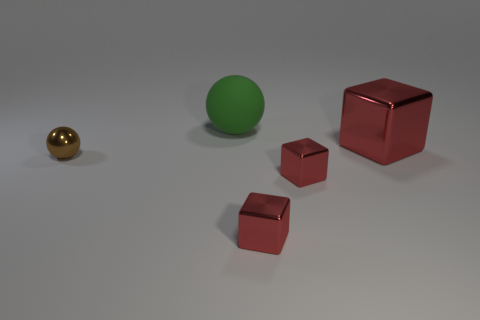What is the shape of the metallic object behind the tiny brown ball?
Ensure brevity in your answer.  Cube. Are the sphere that is behind the big red block and the block behind the small ball made of the same material?
Make the answer very short. No. Is there a small purple shiny object that has the same shape as the big green object?
Offer a very short reply. No. What number of objects are red shiny things on the left side of the large red object or brown shiny objects?
Make the answer very short. 3. Are there more small brown balls behind the large rubber thing than small shiny things in front of the large metallic thing?
Ensure brevity in your answer.  No. What number of metallic things are either green balls or small yellow objects?
Your answer should be compact. 0. Is the number of spheres on the left side of the big green ball less than the number of green balls that are in front of the tiny brown metallic ball?
Offer a terse response. No. What number of objects are either purple shiny balls or tiny things left of the large green rubber sphere?
Offer a very short reply. 1. There is a thing that is the same size as the green rubber sphere; what is it made of?
Your answer should be very brief. Metal. Do the big green object and the large red thing have the same material?
Provide a short and direct response. No. 